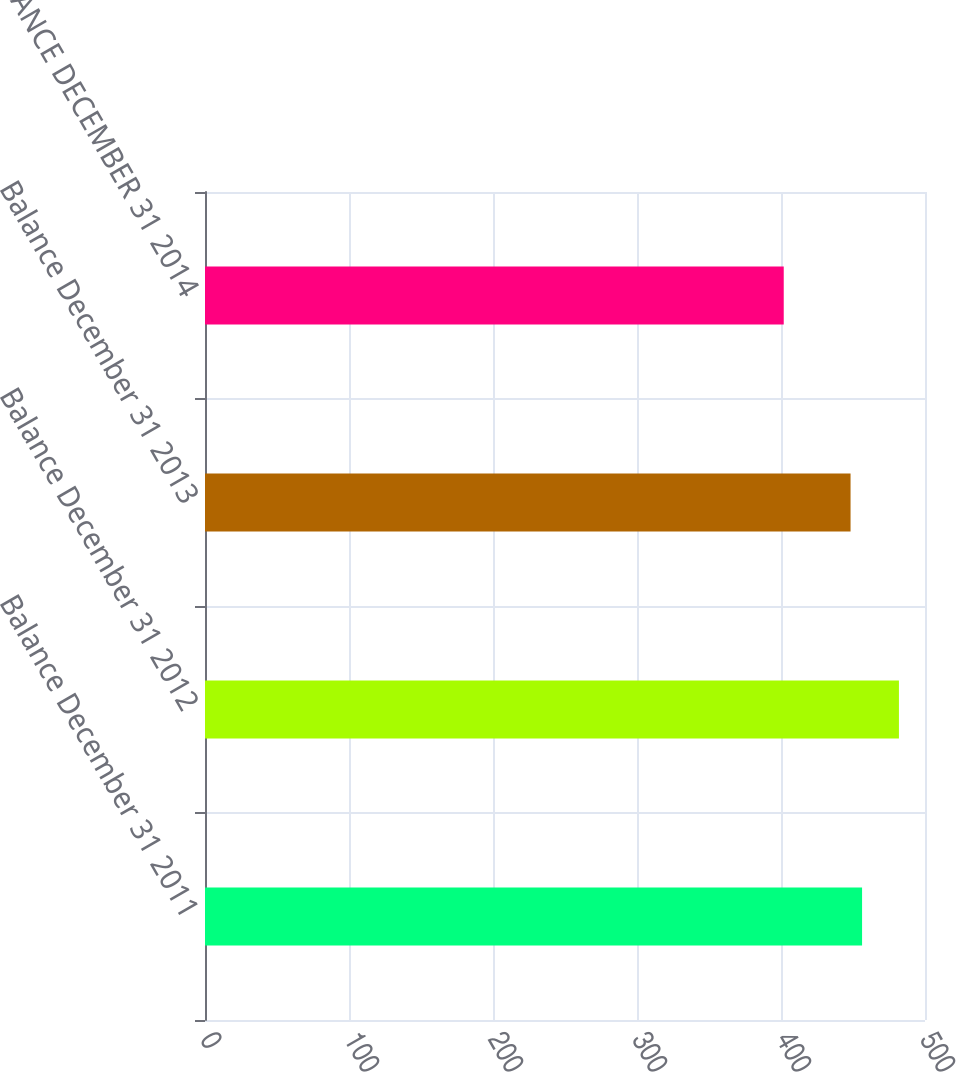Convert chart to OTSL. <chart><loc_0><loc_0><loc_500><loc_500><bar_chart><fcel>Balance December 31 2011<fcel>Balance December 31 2012<fcel>Balance December 31 2013<fcel>BALANCE DECEMBER 31 2014<nl><fcel>456.3<fcel>481.9<fcel>448.3<fcel>401.9<nl></chart> 